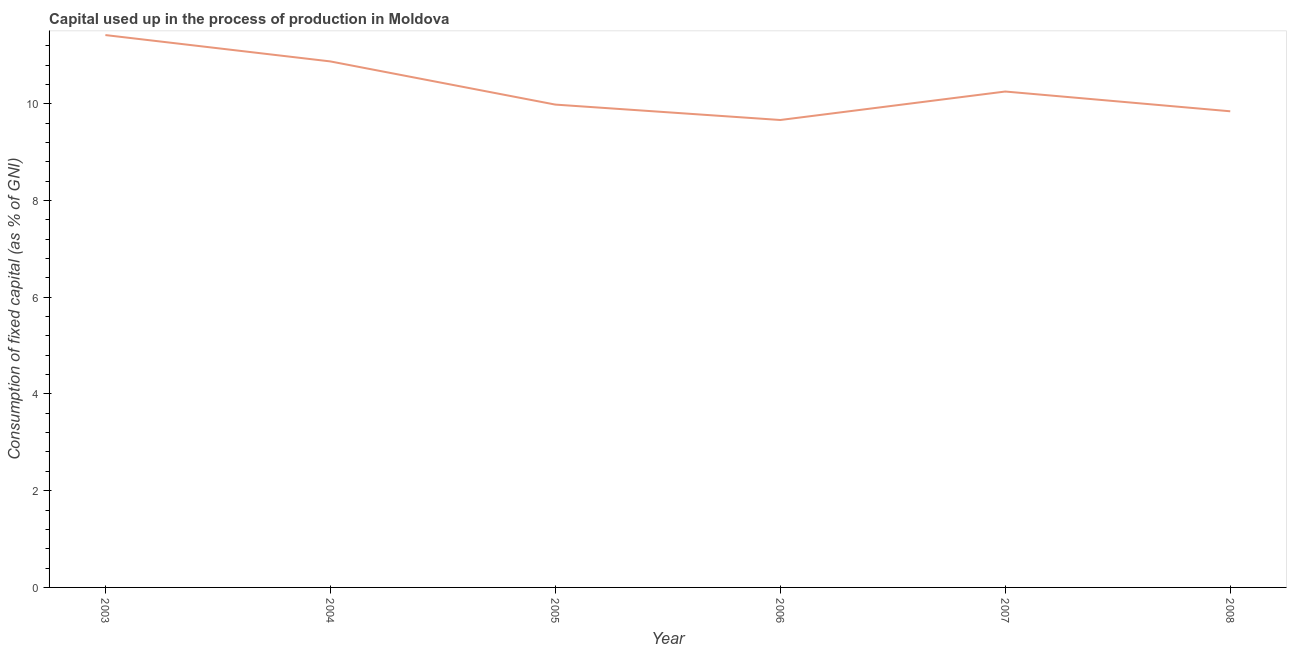What is the consumption of fixed capital in 2008?
Your answer should be compact. 9.84. Across all years, what is the maximum consumption of fixed capital?
Your answer should be compact. 11.42. Across all years, what is the minimum consumption of fixed capital?
Your answer should be compact. 9.66. In which year was the consumption of fixed capital maximum?
Your answer should be compact. 2003. What is the sum of the consumption of fixed capital?
Provide a short and direct response. 62.04. What is the difference between the consumption of fixed capital in 2003 and 2004?
Give a very brief answer. 0.54. What is the average consumption of fixed capital per year?
Make the answer very short. 10.34. What is the median consumption of fixed capital?
Make the answer very short. 10.12. In how many years, is the consumption of fixed capital greater than 2.4 %?
Give a very brief answer. 6. What is the ratio of the consumption of fixed capital in 2003 to that in 2008?
Ensure brevity in your answer.  1.16. Is the consumption of fixed capital in 2007 less than that in 2008?
Your answer should be compact. No. Is the difference between the consumption of fixed capital in 2006 and 2008 greater than the difference between any two years?
Provide a succinct answer. No. What is the difference between the highest and the second highest consumption of fixed capital?
Your answer should be compact. 0.54. What is the difference between the highest and the lowest consumption of fixed capital?
Keep it short and to the point. 1.76. In how many years, is the consumption of fixed capital greater than the average consumption of fixed capital taken over all years?
Your answer should be compact. 2. How many lines are there?
Give a very brief answer. 1. What is the difference between two consecutive major ticks on the Y-axis?
Make the answer very short. 2. Are the values on the major ticks of Y-axis written in scientific E-notation?
Provide a short and direct response. No. Does the graph contain any zero values?
Give a very brief answer. No. Does the graph contain grids?
Offer a very short reply. No. What is the title of the graph?
Provide a short and direct response. Capital used up in the process of production in Moldova. What is the label or title of the X-axis?
Provide a short and direct response. Year. What is the label or title of the Y-axis?
Give a very brief answer. Consumption of fixed capital (as % of GNI). What is the Consumption of fixed capital (as % of GNI) in 2003?
Offer a terse response. 11.42. What is the Consumption of fixed capital (as % of GNI) of 2004?
Offer a terse response. 10.87. What is the Consumption of fixed capital (as % of GNI) in 2005?
Give a very brief answer. 9.98. What is the Consumption of fixed capital (as % of GNI) of 2006?
Offer a very short reply. 9.66. What is the Consumption of fixed capital (as % of GNI) in 2007?
Provide a short and direct response. 10.25. What is the Consumption of fixed capital (as % of GNI) in 2008?
Provide a succinct answer. 9.84. What is the difference between the Consumption of fixed capital (as % of GNI) in 2003 and 2004?
Your response must be concise. 0.54. What is the difference between the Consumption of fixed capital (as % of GNI) in 2003 and 2005?
Offer a very short reply. 1.44. What is the difference between the Consumption of fixed capital (as % of GNI) in 2003 and 2006?
Provide a succinct answer. 1.76. What is the difference between the Consumption of fixed capital (as % of GNI) in 2003 and 2007?
Ensure brevity in your answer.  1.17. What is the difference between the Consumption of fixed capital (as % of GNI) in 2003 and 2008?
Provide a succinct answer. 1.58. What is the difference between the Consumption of fixed capital (as % of GNI) in 2004 and 2005?
Give a very brief answer. 0.89. What is the difference between the Consumption of fixed capital (as % of GNI) in 2004 and 2006?
Ensure brevity in your answer.  1.21. What is the difference between the Consumption of fixed capital (as % of GNI) in 2004 and 2007?
Offer a terse response. 0.62. What is the difference between the Consumption of fixed capital (as % of GNI) in 2004 and 2008?
Your answer should be compact. 1.03. What is the difference between the Consumption of fixed capital (as % of GNI) in 2005 and 2006?
Give a very brief answer. 0.32. What is the difference between the Consumption of fixed capital (as % of GNI) in 2005 and 2007?
Give a very brief answer. -0.27. What is the difference between the Consumption of fixed capital (as % of GNI) in 2005 and 2008?
Your answer should be very brief. 0.14. What is the difference between the Consumption of fixed capital (as % of GNI) in 2006 and 2007?
Make the answer very short. -0.59. What is the difference between the Consumption of fixed capital (as % of GNI) in 2006 and 2008?
Offer a very short reply. -0.18. What is the difference between the Consumption of fixed capital (as % of GNI) in 2007 and 2008?
Your answer should be very brief. 0.41. What is the ratio of the Consumption of fixed capital (as % of GNI) in 2003 to that in 2004?
Provide a succinct answer. 1.05. What is the ratio of the Consumption of fixed capital (as % of GNI) in 2003 to that in 2005?
Give a very brief answer. 1.14. What is the ratio of the Consumption of fixed capital (as % of GNI) in 2003 to that in 2006?
Provide a succinct answer. 1.18. What is the ratio of the Consumption of fixed capital (as % of GNI) in 2003 to that in 2007?
Your response must be concise. 1.11. What is the ratio of the Consumption of fixed capital (as % of GNI) in 2003 to that in 2008?
Provide a succinct answer. 1.16. What is the ratio of the Consumption of fixed capital (as % of GNI) in 2004 to that in 2005?
Your answer should be compact. 1.09. What is the ratio of the Consumption of fixed capital (as % of GNI) in 2004 to that in 2007?
Offer a terse response. 1.06. What is the ratio of the Consumption of fixed capital (as % of GNI) in 2004 to that in 2008?
Ensure brevity in your answer.  1.1. What is the ratio of the Consumption of fixed capital (as % of GNI) in 2005 to that in 2006?
Offer a terse response. 1.03. What is the ratio of the Consumption of fixed capital (as % of GNI) in 2005 to that in 2007?
Keep it short and to the point. 0.97. What is the ratio of the Consumption of fixed capital (as % of GNI) in 2005 to that in 2008?
Provide a short and direct response. 1.01. What is the ratio of the Consumption of fixed capital (as % of GNI) in 2006 to that in 2007?
Your answer should be very brief. 0.94. What is the ratio of the Consumption of fixed capital (as % of GNI) in 2006 to that in 2008?
Offer a very short reply. 0.98. What is the ratio of the Consumption of fixed capital (as % of GNI) in 2007 to that in 2008?
Provide a succinct answer. 1.04. 